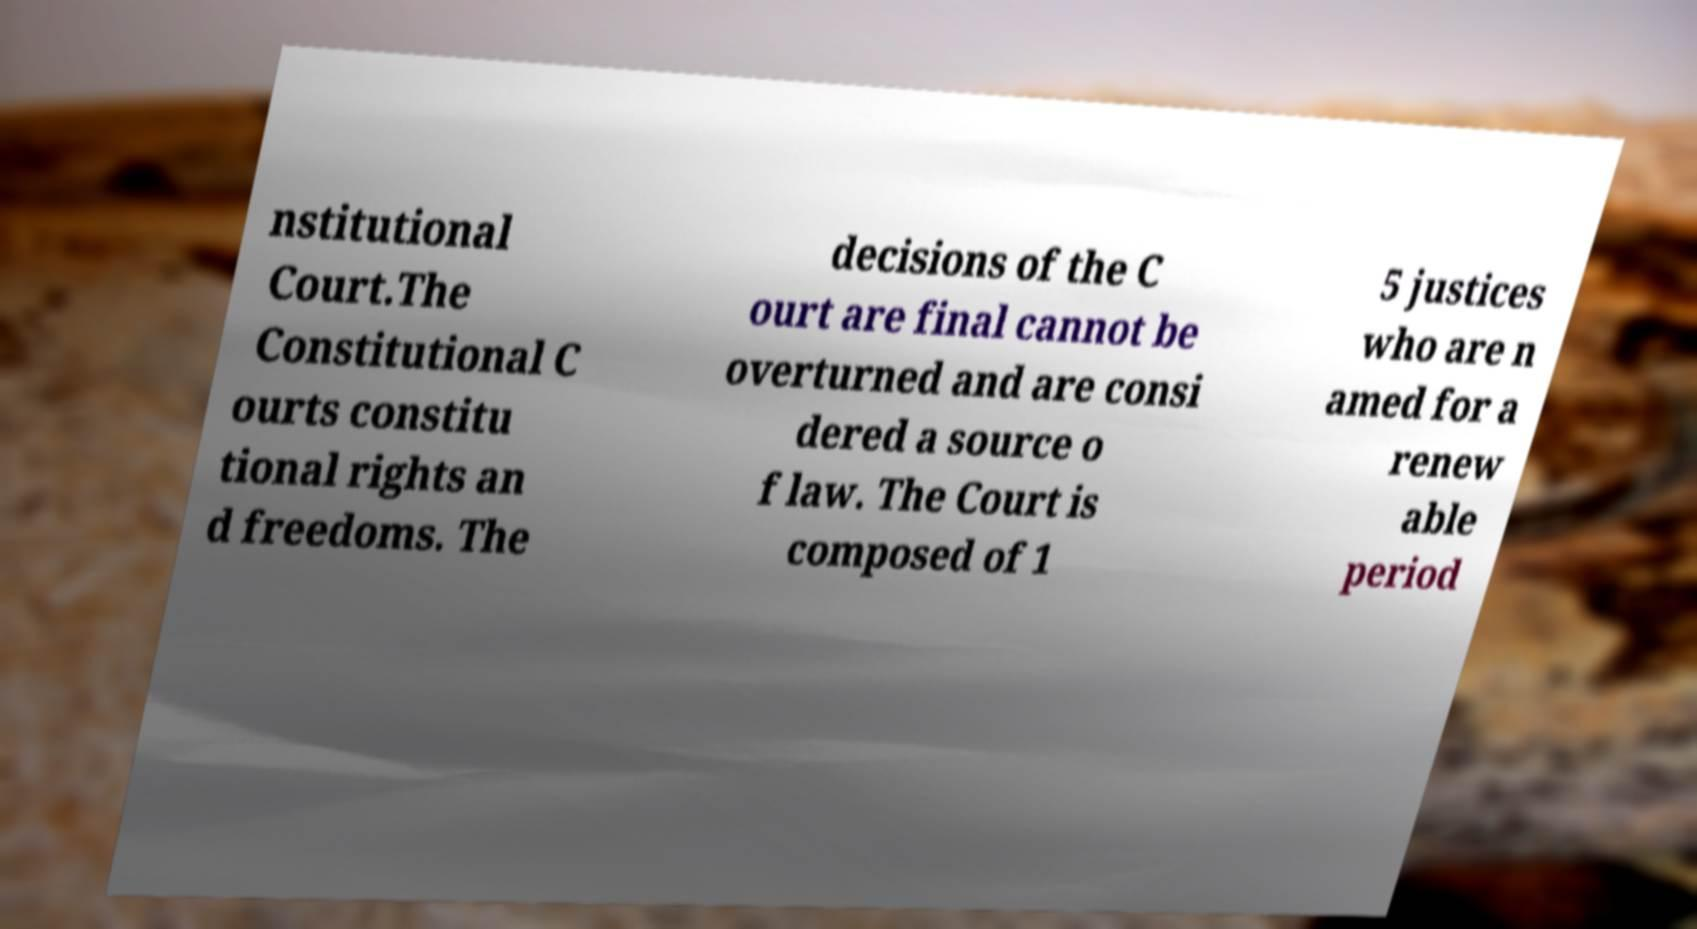For documentation purposes, I need the text within this image transcribed. Could you provide that? nstitutional Court.The Constitutional C ourts constitu tional rights an d freedoms. The decisions of the C ourt are final cannot be overturned and are consi dered a source o f law. The Court is composed of 1 5 justices who are n amed for a renew able period 